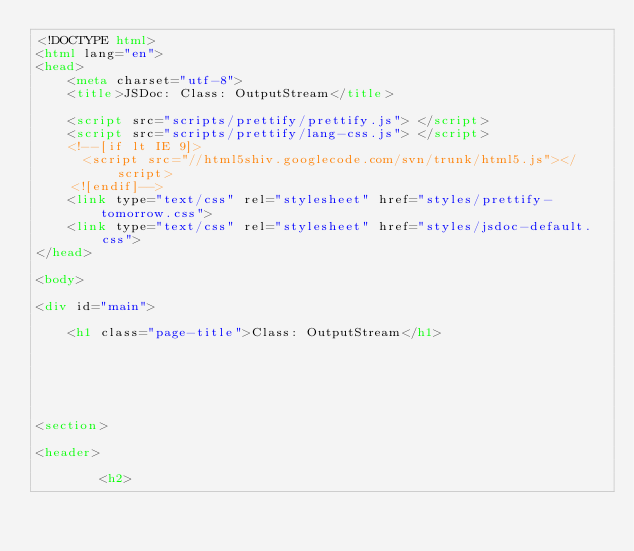<code> <loc_0><loc_0><loc_500><loc_500><_HTML_><!DOCTYPE html>
<html lang="en">
<head>
    <meta charset="utf-8">
    <title>JSDoc: Class: OutputStream</title>

    <script src="scripts/prettify/prettify.js"> </script>
    <script src="scripts/prettify/lang-css.js"> </script>
    <!--[if lt IE 9]>
      <script src="//html5shiv.googlecode.com/svn/trunk/html5.js"></script>
    <![endif]-->
    <link type="text/css" rel="stylesheet" href="styles/prettify-tomorrow.css">
    <link type="text/css" rel="stylesheet" href="styles/jsdoc-default.css">
</head>

<body>

<div id="main">

    <h1 class="page-title">Class: OutputStream</h1>

    




<section>

<header>
    
        <h2></code> 